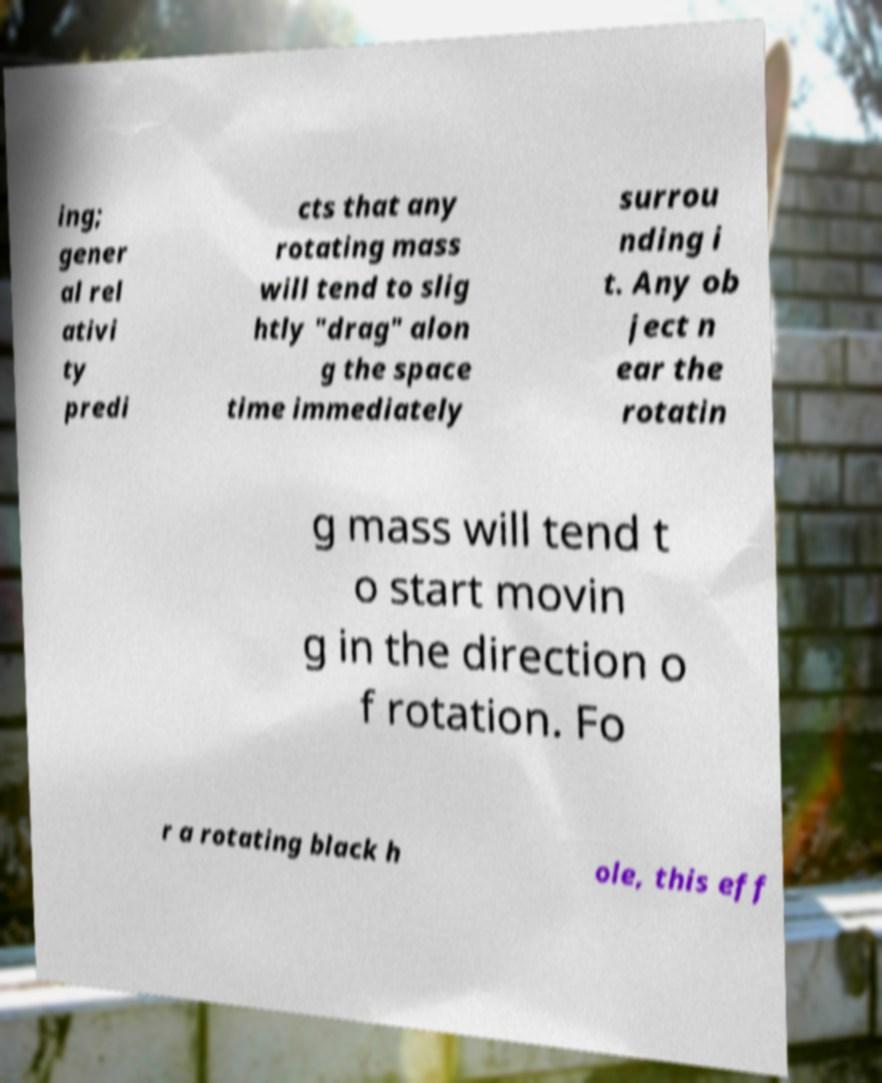There's text embedded in this image that I need extracted. Can you transcribe it verbatim? ing; gener al rel ativi ty predi cts that any rotating mass will tend to slig htly "drag" alon g the space time immediately surrou nding i t. Any ob ject n ear the rotatin g mass will tend t o start movin g in the direction o f rotation. Fo r a rotating black h ole, this eff 